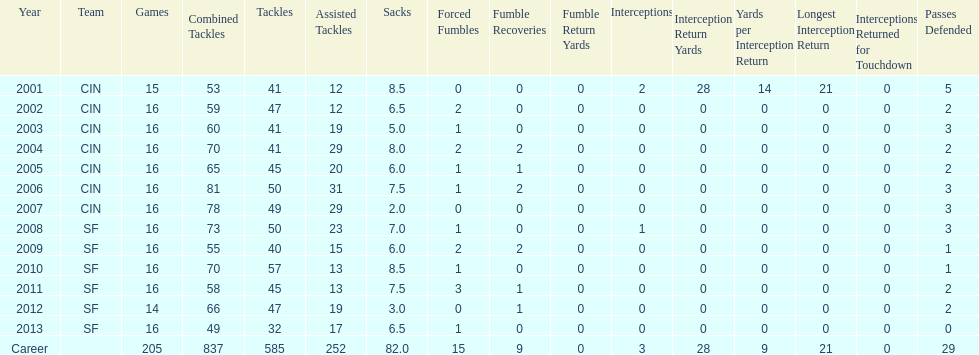Over how many years did his playtime include no fumble recoveries? 7. 